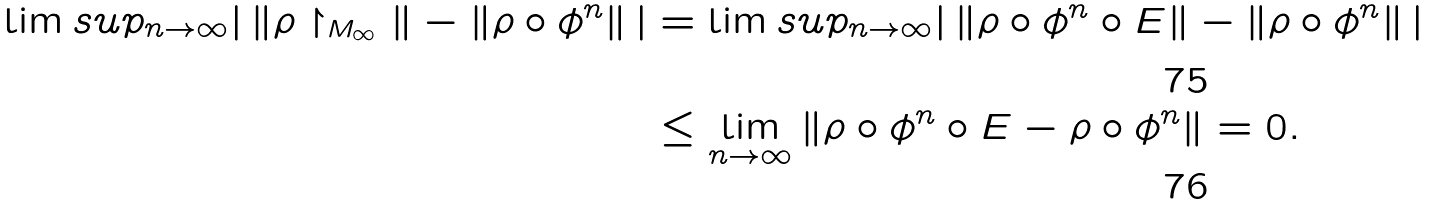<formula> <loc_0><loc_0><loc_500><loc_500>\lim s u p _ { n \to \infty } | \, \| \rho \restriction _ { M _ { \infty } } \| - \| \rho \circ \phi ^ { n } \| \, | & = \lim s u p _ { n \to \infty } | \, \| \rho \circ \phi ^ { n } \circ E \| - \| \rho \circ \phi ^ { n } \| \, | \\ & \leq \lim _ { n \to \infty } \| \rho \circ \phi ^ { n } \circ E - \rho \circ \phi ^ { n } \| = 0 .</formula> 